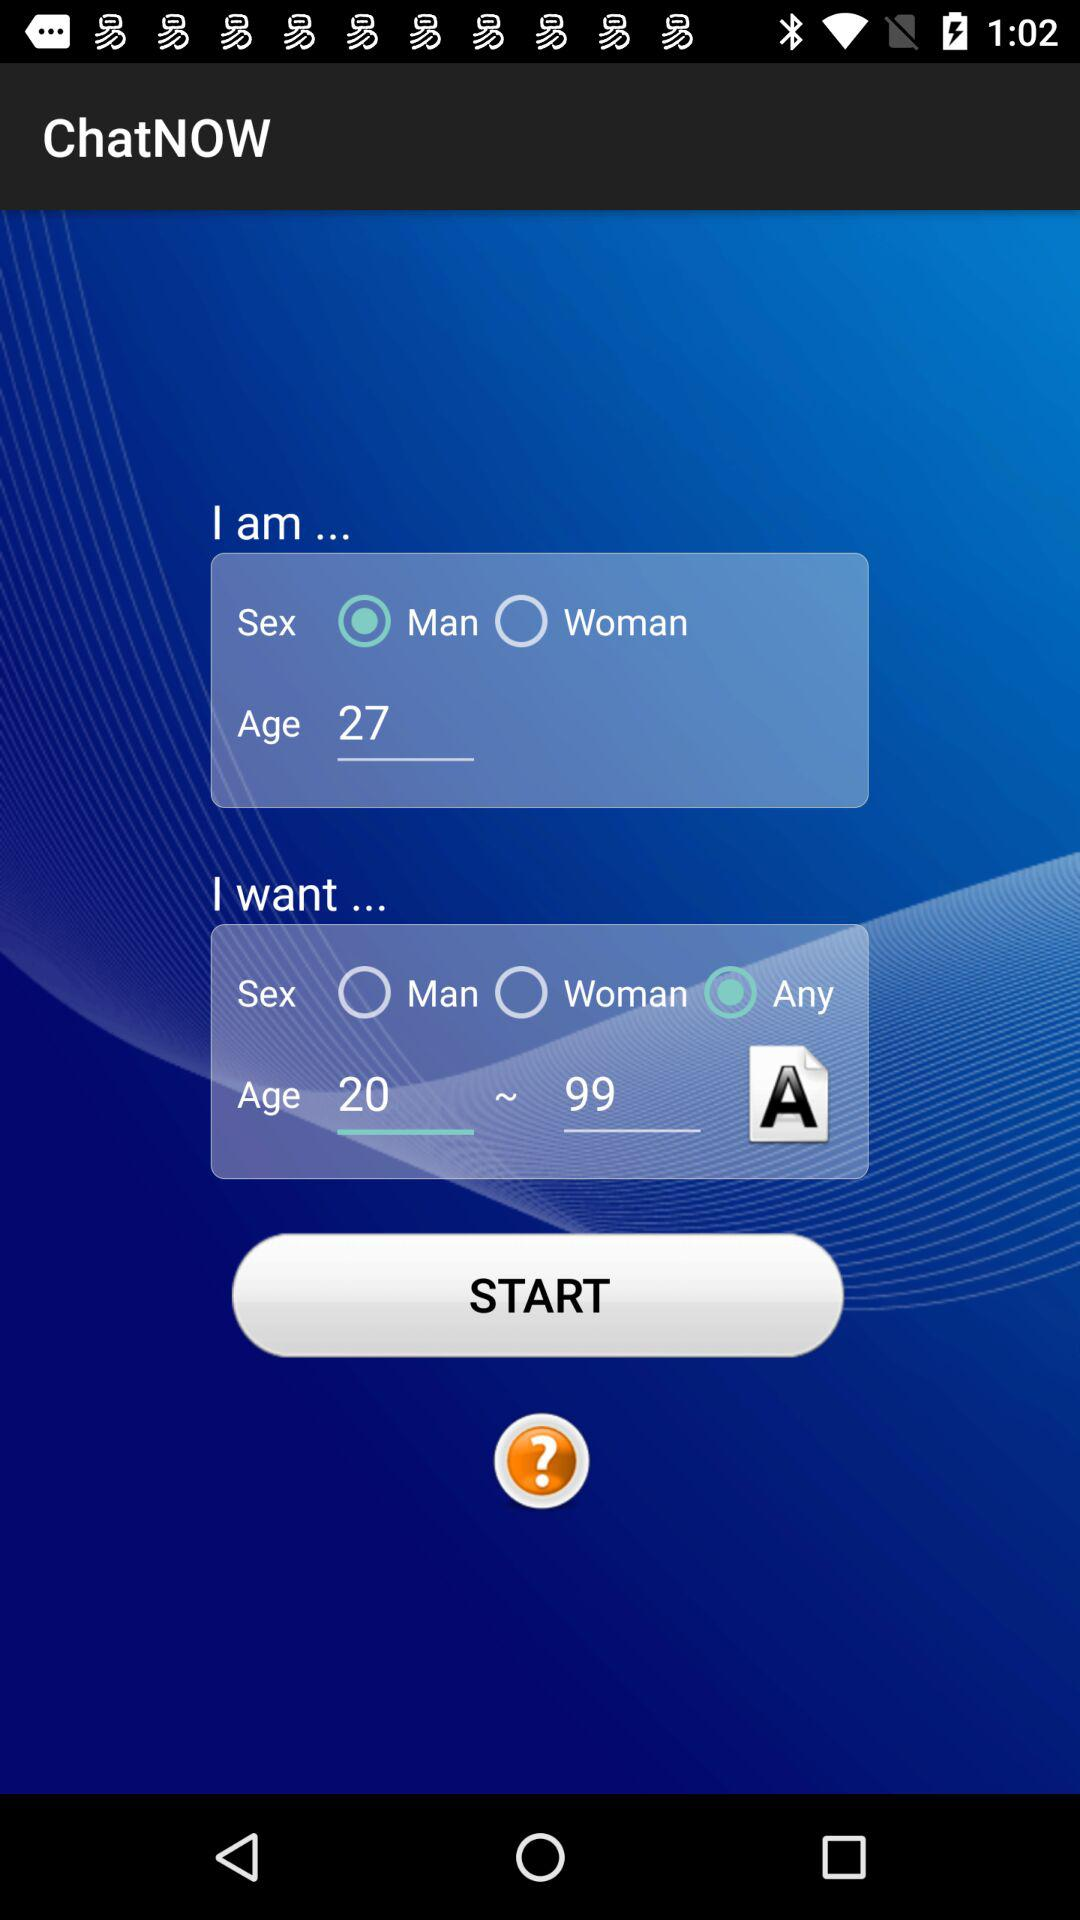What is the age given here? The given age is 27. 